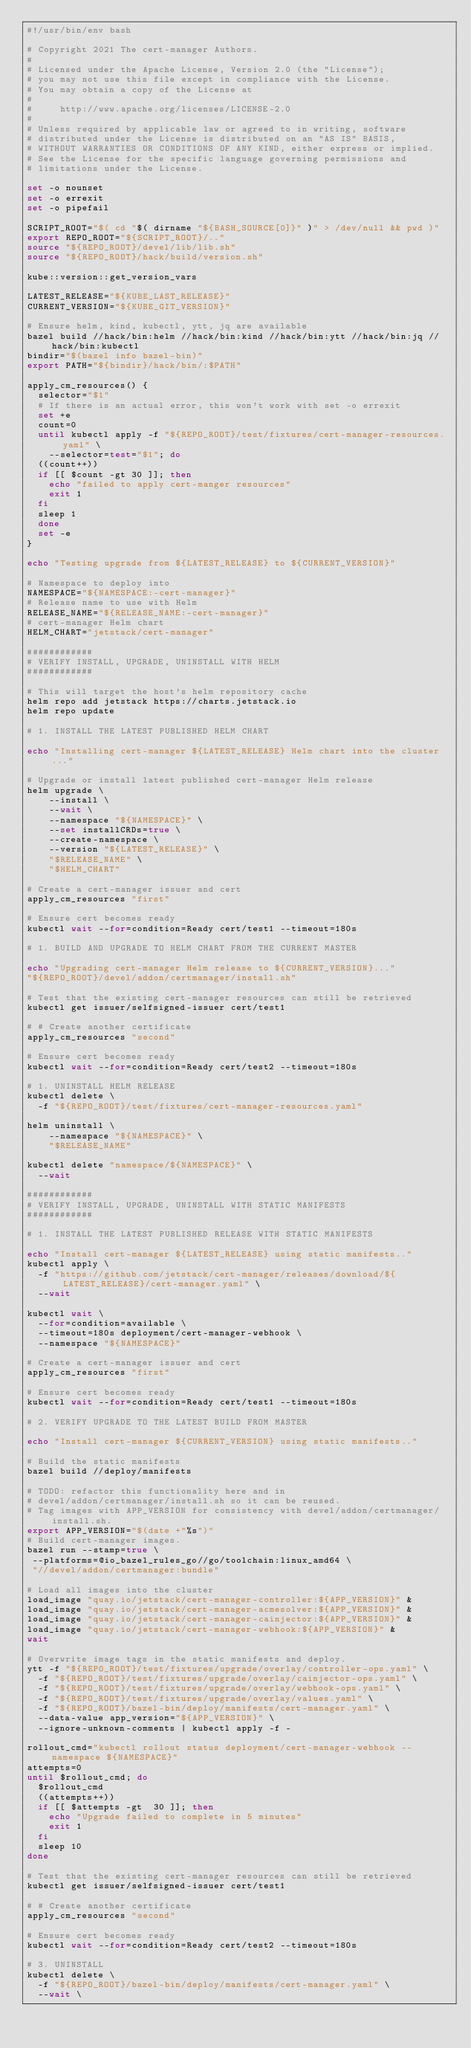Convert code to text. <code><loc_0><loc_0><loc_500><loc_500><_Bash_>#!/usr/bin/env bash

# Copyright 2021 The cert-manager Authors.
#
# Licensed under the Apache License, Version 2.0 (the "License");
# you may not use this file except in compliance with the License.
# You may obtain a copy of the License at
#
#     http://www.apache.org/licenses/LICENSE-2.0
#
# Unless required by applicable law or agreed to in writing, software
# distributed under the License is distributed on an "AS IS" BASIS,
# WITHOUT WARRANTIES OR CONDITIONS OF ANY KIND, either express or implied.
# See the License for the specific language governing permissions and
# limitations under the License.

set -o nounset
set -o errexit
set -o pipefail

SCRIPT_ROOT="$( cd "$( dirname "${BASH_SOURCE[0]}" )" > /dev/null && pwd )"
export REPO_ROOT="${SCRIPT_ROOT}/.."
source "${REPO_ROOT}/devel/lib/lib.sh"
source "${REPO_ROOT}/hack/build/version.sh"

kube::version::get_version_vars

LATEST_RELEASE="${KUBE_LAST_RELEASE}"
CURRENT_VERSION="${KUBE_GIT_VERSION}"

# Ensure helm, kind, kubectl, ytt, jq are available
bazel build //hack/bin:helm //hack/bin:kind //hack/bin:ytt //hack/bin:jq //hack/bin:kubectl
bindir="$(bazel info bazel-bin)"
export PATH="${bindir}/hack/bin/:$PATH"

apply_cm_resources() {
	selector="$1"
	# If there is an actual error, this won't work with set -o errexit
	set +e
	count=0
	until kubectl apply -f "${REPO_ROOT}/test/fixtures/cert-manager-resources.yaml" \
		--selector=test="$1"; do
	((count++))
	if [[ $count -gt 30 ]]; then
		echo "failed to apply cert-manger resources"
		exit 1
	fi
	sleep 1
	done
	set -e
}

echo "Testing upgrade from ${LATEST_RELEASE} to ${CURRENT_VERSION}"

# Namespace to deploy into
NAMESPACE="${NAMESPACE:-cert-manager}"
# Release name to use with Helm
RELEASE_NAME="${RELEASE_NAME:-cert-manager}"
# cert-manager Helm chart
HELM_CHART="jetstack/cert-manager"

############
# VERIFY INSTALL, UPGRADE, UNINSTALL WITH HELM
############

# This will target the host's helm repository cache
helm repo add jetstack https://charts.jetstack.io
helm repo update

# 1. INSTALL THE LATEST PUBLISHED HELM CHART

echo "Installing cert-manager ${LATEST_RELEASE} Helm chart into the cluster..."

# Upgrade or install latest published cert-manager Helm release
helm upgrade \
    --install \
    --wait \
    --namespace "${NAMESPACE}" \
    --set installCRDs=true \
    --create-namespace \
    --version "${LATEST_RELEASE}" \
    "$RELEASE_NAME" \
    "$HELM_CHART"

# Create a cert-manager issuer and cert
apply_cm_resources "first"

# Ensure cert becomes ready
kubectl wait --for=condition=Ready cert/test1 --timeout=180s

# 1. BUILD AND UPGRADE TO HELM CHART FROM THE CURRENT MASTER

echo "Upgrading cert-manager Helm release to ${CURRENT_VERSION}..."
"${REPO_ROOT}/devel/addon/certmanager/install.sh"

# Test that the existing cert-manager resources can still be retrieved
kubectl get issuer/selfsigned-issuer cert/test1

# # Create another certificate
apply_cm_resources "second"

# Ensure cert becomes ready
kubectl wait --for=condition=Ready cert/test2 --timeout=180s

# 1. UNINSTALL HELM RELEASE
kubectl delete \
	-f "${REPO_ROOT}/test/fixtures/cert-manager-resources.yaml"

helm uninstall \
    --namespace "${NAMESPACE}" \
    "$RELEASE_NAME"

kubectl delete "namespace/${NAMESPACE}" \
	--wait

############
# VERIFY INSTALL, UPGRADE, UNINSTALL WITH STATIC MANIFESTS
############

# 1. INSTALL THE LATEST PUBLISHED RELEASE WITH STATIC MANIFESTS

echo "Install cert-manager ${LATEST_RELEASE} using static manifests.."
kubectl apply \
	-f "https://github.com/jetstack/cert-manager/releases/download/${LATEST_RELEASE}/cert-manager.yaml" \
	--wait

kubectl wait \
	--for=condition=available \
	--timeout=180s deployment/cert-manager-webhook \
	--namespace "${NAMESPACE}"

# Create a cert-manager issuer and cert
apply_cm_resources "first"

# Ensure cert becomes ready
kubectl wait --for=condition=Ready cert/test1 --timeout=180s

# 2. VERIFY UPGRADE TO THE LATEST BUILD FROM MASTER

echo "Install cert-manager ${CURRENT_VERSION} using static manifests.."

# Build the static manifests
bazel build //deploy/manifests

# TODO: refactor this functionality here and in
# devel/addon/certmanager/install.sh so it can be reused.
# Tag images with APP_VERSION for consistency with devel/addon/certmanager/install.sh.
export APP_VERSION="$(date +"%s")"
# Build cert-manager images.
bazel run --stamp=true \
 --platforms=@io_bazel_rules_go//go/toolchain:linux_amd64 \
 "//devel/addon/certmanager:bundle"

# Load all images into the cluster
load_image "quay.io/jetstack/cert-manager-controller:${APP_VERSION}" &
load_image "quay.io/jetstack/cert-manager-acmesolver:${APP_VERSION}" &
load_image "quay.io/jetstack/cert-manager-cainjector:${APP_VERSION}" &
load_image "quay.io/jetstack/cert-manager-webhook:${APP_VERSION}" &
wait

# Overwrite image tags in the static manifests and deploy.
ytt -f "${REPO_ROOT}/test/fixtures/upgrade/overlay/controller-ops.yaml" \
	-f "${REPO_ROOT}/test/fixtures/upgrade/overlay/cainjector-ops.yaml" \
	-f "${REPO_ROOT}/test/fixtures/upgrade/overlay/webhook-ops.yaml" \
	-f "${REPO_ROOT}/test/fixtures/upgrade/overlay/values.yaml" \
	-f "${REPO_ROOT}/bazel-bin/deploy/manifests/cert-manager.yaml" \
	--data-value app_version="${APP_VERSION}" \
	--ignore-unknown-comments | kubectl apply -f -

rollout_cmd="kubectl rollout status deployment/cert-manager-webhook --namespace ${NAMESPACE}"
attempts=0
until $rollout_cmd; do
  $rollout_cmd
  ((attempts++))
  if [[ $attempts -gt  30 ]]; then
    echo "Upgrade failed to complete in 5 minutes"
    exit 1
  fi
  sleep 10
done

# Test that the existing cert-manager resources can still be retrieved
kubectl get issuer/selfsigned-issuer cert/test1

# # Create another certificate
apply_cm_resources "second"

# Ensure cert becomes ready
kubectl wait --for=condition=Ready cert/test2 --timeout=180s

# 3. UNINSTALL
kubectl delete \
	-f "${REPO_ROOT}/bazel-bin/deploy/manifests/cert-manager.yaml" \
	--wait \
</code> 